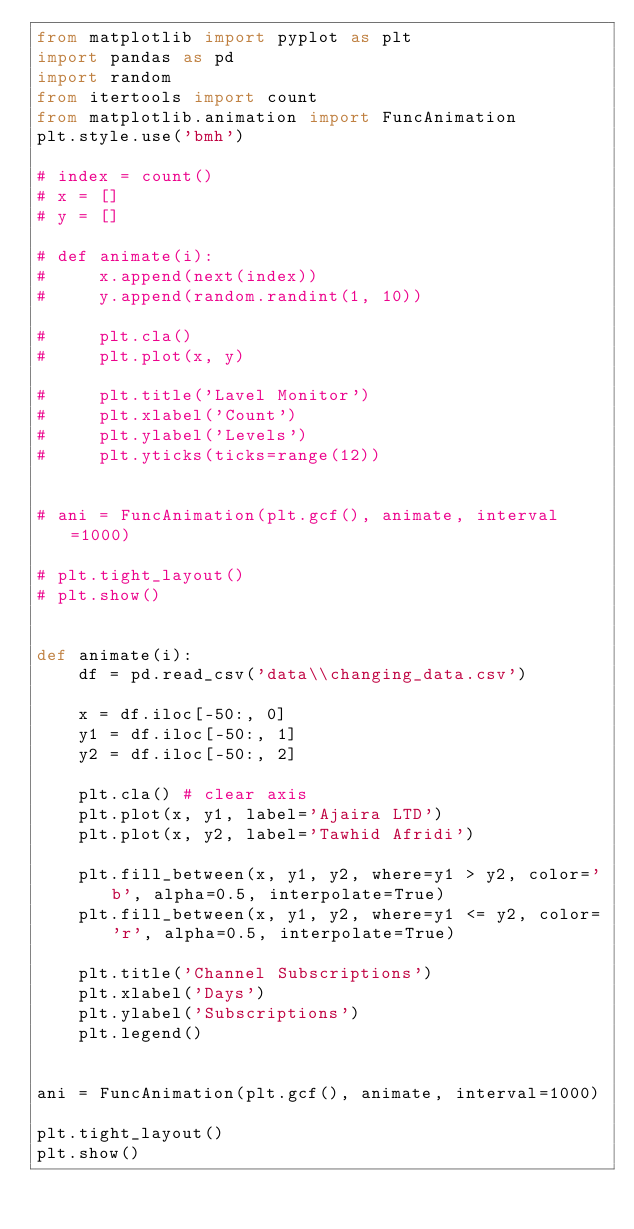Convert code to text. <code><loc_0><loc_0><loc_500><loc_500><_Python_>from matplotlib import pyplot as plt
import pandas as pd
import random
from itertools import count
from matplotlib.animation import FuncAnimation
plt.style.use('bmh')

# index = count()
# x = []
# y = []

# def animate(i):
#     x.append(next(index))
#     y.append(random.randint(1, 10))

#     plt.cla()
#     plt.plot(x, y)

#     plt.title('Lavel Monitor')
#     plt.xlabel('Count')
#     plt.ylabel('Levels')
#     plt.yticks(ticks=range(12))


# ani = FuncAnimation(plt.gcf(), animate, interval=1000)

# plt.tight_layout()
# plt.show()


def animate(i):
    df = pd.read_csv('data\\changing_data.csv')

    x = df.iloc[-50:, 0]
    y1 = df.iloc[-50:, 1]
    y2 = df.iloc[-50:, 2]

    plt.cla() # clear axis
    plt.plot(x, y1, label='Ajaira LTD')
    plt.plot(x, y2, label='Tawhid Afridi')

    plt.fill_between(x, y1, y2, where=y1 > y2, color='b', alpha=0.5, interpolate=True)
    plt.fill_between(x, y1, y2, where=y1 <= y2, color='r', alpha=0.5, interpolate=True)

    plt.title('Channel Subscriptions')
    plt.xlabel('Days')
    plt.ylabel('Subscriptions')
    plt.legend()


ani = FuncAnimation(plt.gcf(), animate, interval=1000)

plt.tight_layout()
plt.show()
</code> 